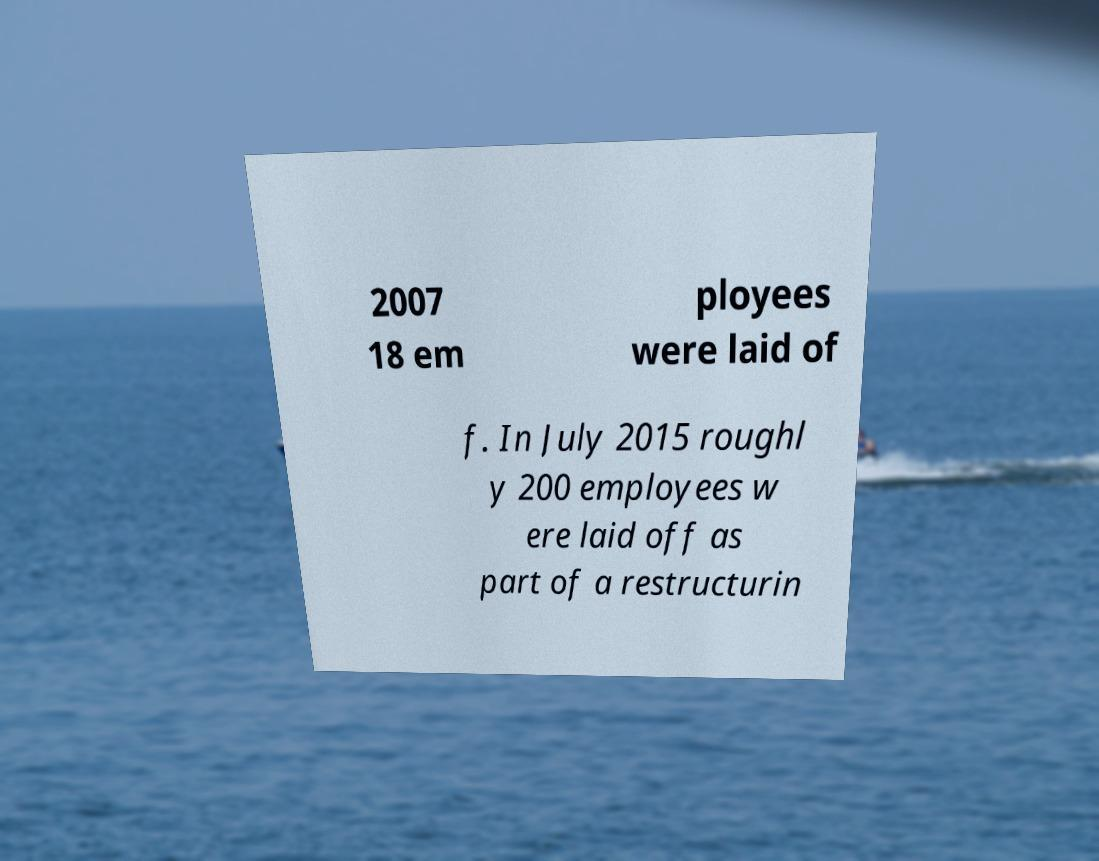Please read and relay the text visible in this image. What does it say? 2007 18 em ployees were laid of f. In July 2015 roughl y 200 employees w ere laid off as part of a restructurin 